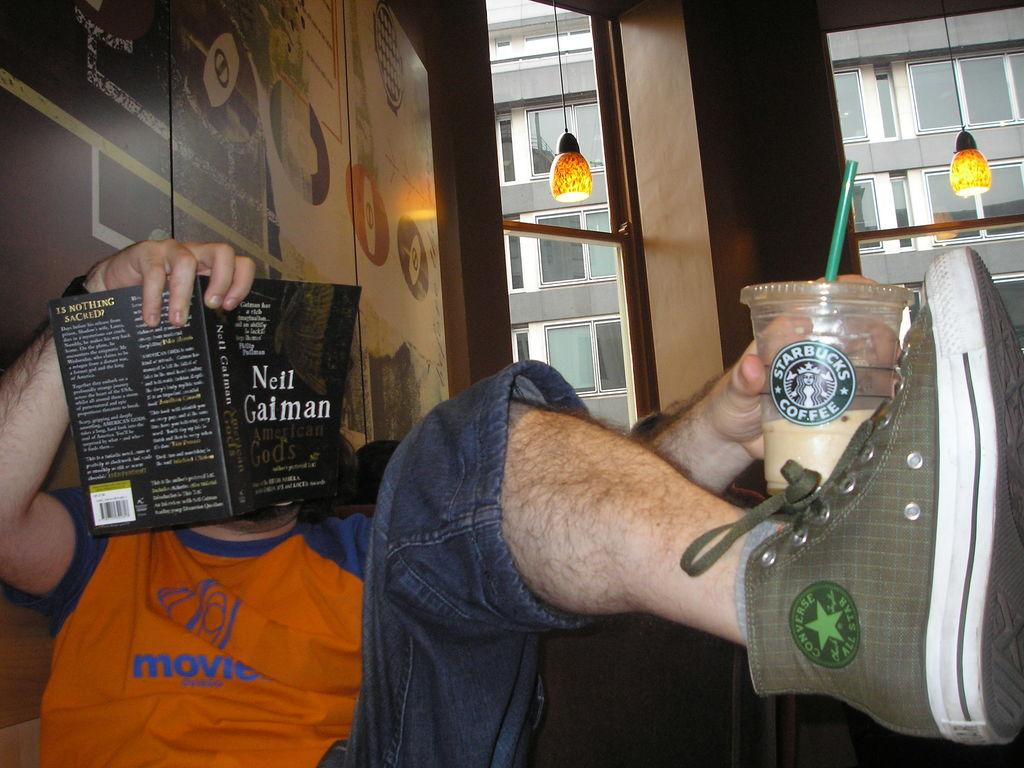<image>
Describe the image concisely. Man reading a book with his leg up while holding a Starbucks Coffee cup. 